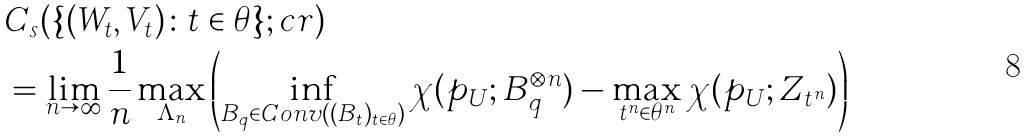Convert formula to latex. <formula><loc_0><loc_0><loc_500><loc_500>& C _ { s } ( \{ ( W _ { t } , { V } _ { t } ) \colon t \in \theta \} ; c r ) \\ & = \lim _ { n \rightarrow \infty } \frac { 1 } { n } \max _ { \Lambda _ { n } } \left ( \inf _ { B _ { q } \in C o n v ( ( B _ { t } ) _ { t \in \theta } ) } \chi ( p _ { U } ; B _ { q } ^ { \otimes n } ) - \max _ { t ^ { n } \in \theta ^ { n } } \chi ( p _ { U } ; Z _ { t ^ { n } } ) \right )</formula> 